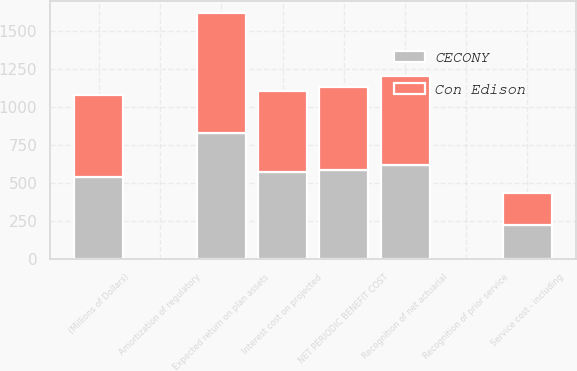Convert chart. <chart><loc_0><loc_0><loc_500><loc_500><stacked_bar_chart><ecel><fcel>(Millions of Dollars)<fcel>Service cost - including<fcel>Interest cost on projected<fcel>Expected return on plan assets<fcel>Recognition of net actuarial<fcel>Recognition of prior service<fcel>NET PERIODIC BENEFIT COST<fcel>Amortization of regulatory<nl><fcel>CECONY<fcel>541<fcel>227<fcel>572<fcel>832<fcel>618<fcel>4<fcel>589<fcel>2<nl><fcel>Con Edison<fcel>541<fcel>211<fcel>536<fcel>789<fcel>586<fcel>2<fcel>546<fcel>2<nl></chart> 